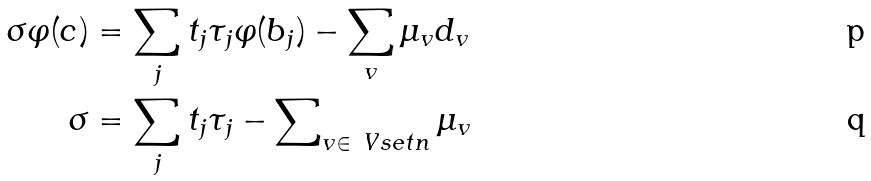Convert formula to latex. <formula><loc_0><loc_0><loc_500><loc_500>\sigma \varphi ( c ) & = \sum _ { j } t _ { j } \tau _ { j } \varphi ( b _ { j } ) - \sum _ { v } \mu _ { v } d _ { v } \\ \sigma & = \sum _ { j } t _ { j } \tau _ { j } - \sum \nolimits _ { v \in \ V s e t n } \mu _ { v }</formula> 